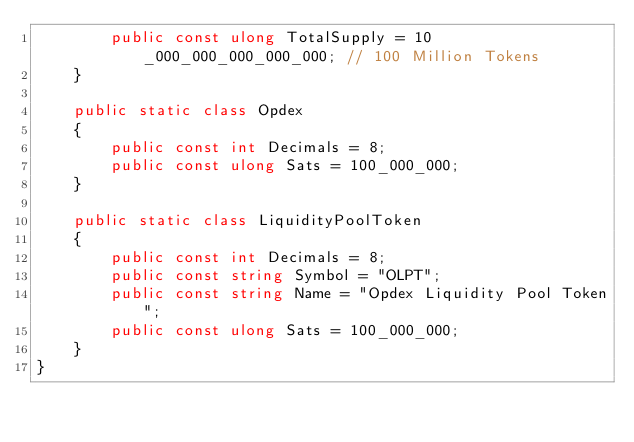Convert code to text. <code><loc_0><loc_0><loc_500><loc_500><_C#_>        public const ulong TotalSupply = 10_000_000_000_000_000; // 100 Million Tokens
    }

    public static class Opdex
    {
        public const int Decimals = 8;
        public const ulong Sats = 100_000_000;
    }

    public static class LiquidityPoolToken
    {
        public const int Decimals = 8;
        public const string Symbol = "OLPT";
        public const string Name = "Opdex Liquidity Pool Token";
        public const ulong Sats = 100_000_000;
    }
}
</code> 